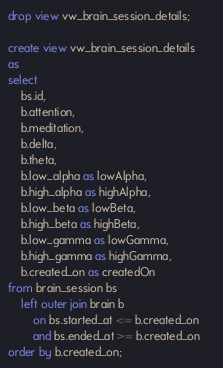<code> <loc_0><loc_0><loc_500><loc_500><_SQL_>drop view vw_brain_session_details;

create view vw_brain_session_details
as
select 
    bs.id,
    b.attention,
    b.meditation,
    b.delta,
    b.theta,
    b.low_alpha as lowAlpha,
    b.high_alpha as highAlpha,
    b.low_beta as lowBeta,
    b.high_beta as highBeta,
    b.low_gamma as lowGamma,
    b.high_gamma as highGamma,
    b.created_on as createdOn
from brain_session bs
    left outer join brain b
        on bs.started_at <= b.created_on     
        and bs.ended_at >= b.created_on
order by b.created_on;       </code> 